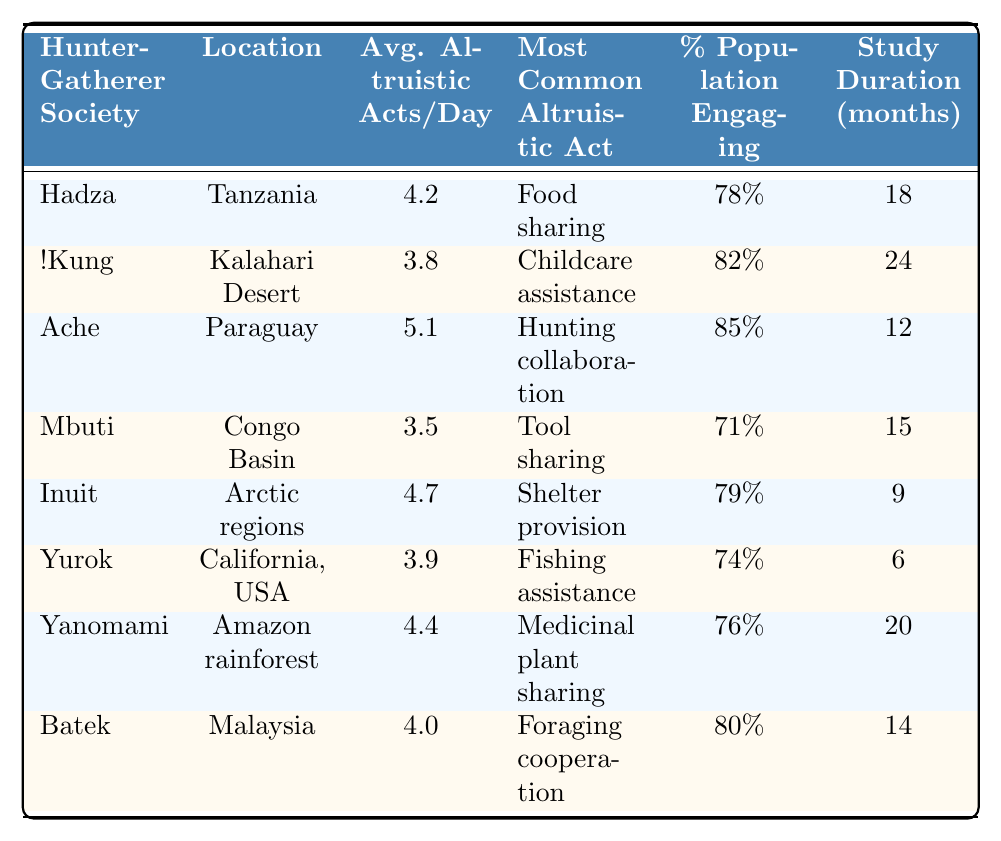What is the average number of altruistic acts per day for the Ache society? The table shows that the Ache society has an average of 5.1 altruistic acts per day listed under the "Average Altruistic Acts per Day" column.
Answer: 5.1 Which society has the highest percentage of its population engaging in altruistic acts? Looking through the "Percentage of Population Engaging in Altruism" column, the Ache society has the highest value at 85%.
Answer: Ache How many months was the study conducted for the !Kung society? The study duration for the !Kung society is listed as 24 months in the "Study Duration (months)" column.
Answer: 24 What is the most common altruistic act observed among the Inuit? The table indicates that the most common altruistic act among the Inuit is "Shelter provision."
Answer: Shelter provision What is the average number of altruistic acts per day across all societies listed? First, sum the average altruistic acts of all societies: (4.2 + 3.8 + 5.1 + 3.5 + 4.7 + 3.9 + 4.4 + 4.0) = 33.7, then divide by the number of societies (8): 33.7 / 8 = 4.2125. The rounded average is approximately 4.2.
Answer: 4.2 Is food sharing the most common altruistic act among all societies listed? By checking the most common altruistic acts for each society, only the Hadza has food sharing as the most common act, while others vary (e.g., childcare assistance, hunting collaboration), so the answer is no.
Answer: No Which society has the lowest average number of altruistic acts per day, and what is that number? Review the "Average Altruistic Acts per Day" column, where the Mbuti society shows the lowest value at 3.5.
Answer: 3.5 If the Hadza society engages in altruism at a rate of 4.2 acts per day, how does this compare to the Yurok society? Comparing the average acts, the Hadza engages in 4.2 while the Yurok engages in 3.9 acts per day. Therefore, Hadza has 0.3 more altruistic acts per day than Yurok.
Answer: 0.3 more Which societies engage in altruism at a percentage higher than 75%? Reviewing the "Percentage of Population Engaging in Altruism," the Ache (85%), !Kung (82%), Inuit (79%), and Batek (80%) all exceed 75%.
Answer: Ache, !Kung, Inuit, Batek What is the total duration of studies conducted across all societies? Calculate the total study duration by summing all entries in the "Study Duration (months)" column: 18 + 24 + 12 + 15 + 9 + 6 + 20 + 14 = 118 months for all societies.
Answer: 118 months 